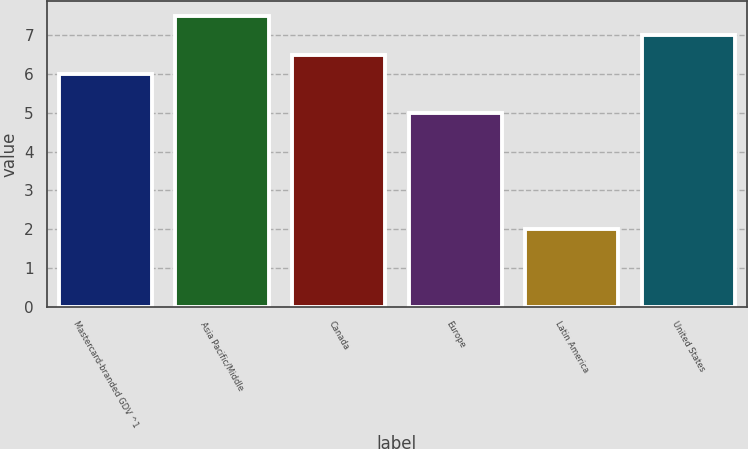<chart> <loc_0><loc_0><loc_500><loc_500><bar_chart><fcel>Mastercard-branded GDV ^1<fcel>Asia Pacific/Middle<fcel>Canada<fcel>Europe<fcel>Latin America<fcel>United States<nl><fcel>6<fcel>7.5<fcel>6.5<fcel>5<fcel>2<fcel>7<nl></chart> 